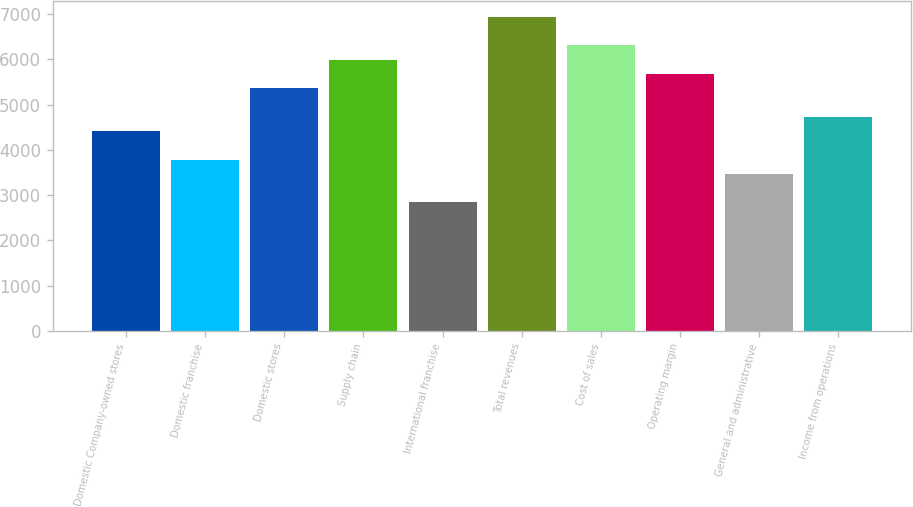<chart> <loc_0><loc_0><loc_500><loc_500><bar_chart><fcel>Domestic Company-owned stores<fcel>Domestic franchise<fcel>Domestic stores<fcel>Supply chain<fcel>International franchise<fcel>Total revenues<fcel>Cost of sales<fcel>Operating margin<fcel>General and administrative<fcel>Income from operations<nl><fcel>4414.72<fcel>3784.26<fcel>5360.41<fcel>5990.87<fcel>2838.57<fcel>6936.56<fcel>6306.1<fcel>5675.64<fcel>3469.03<fcel>4729.95<nl></chart> 